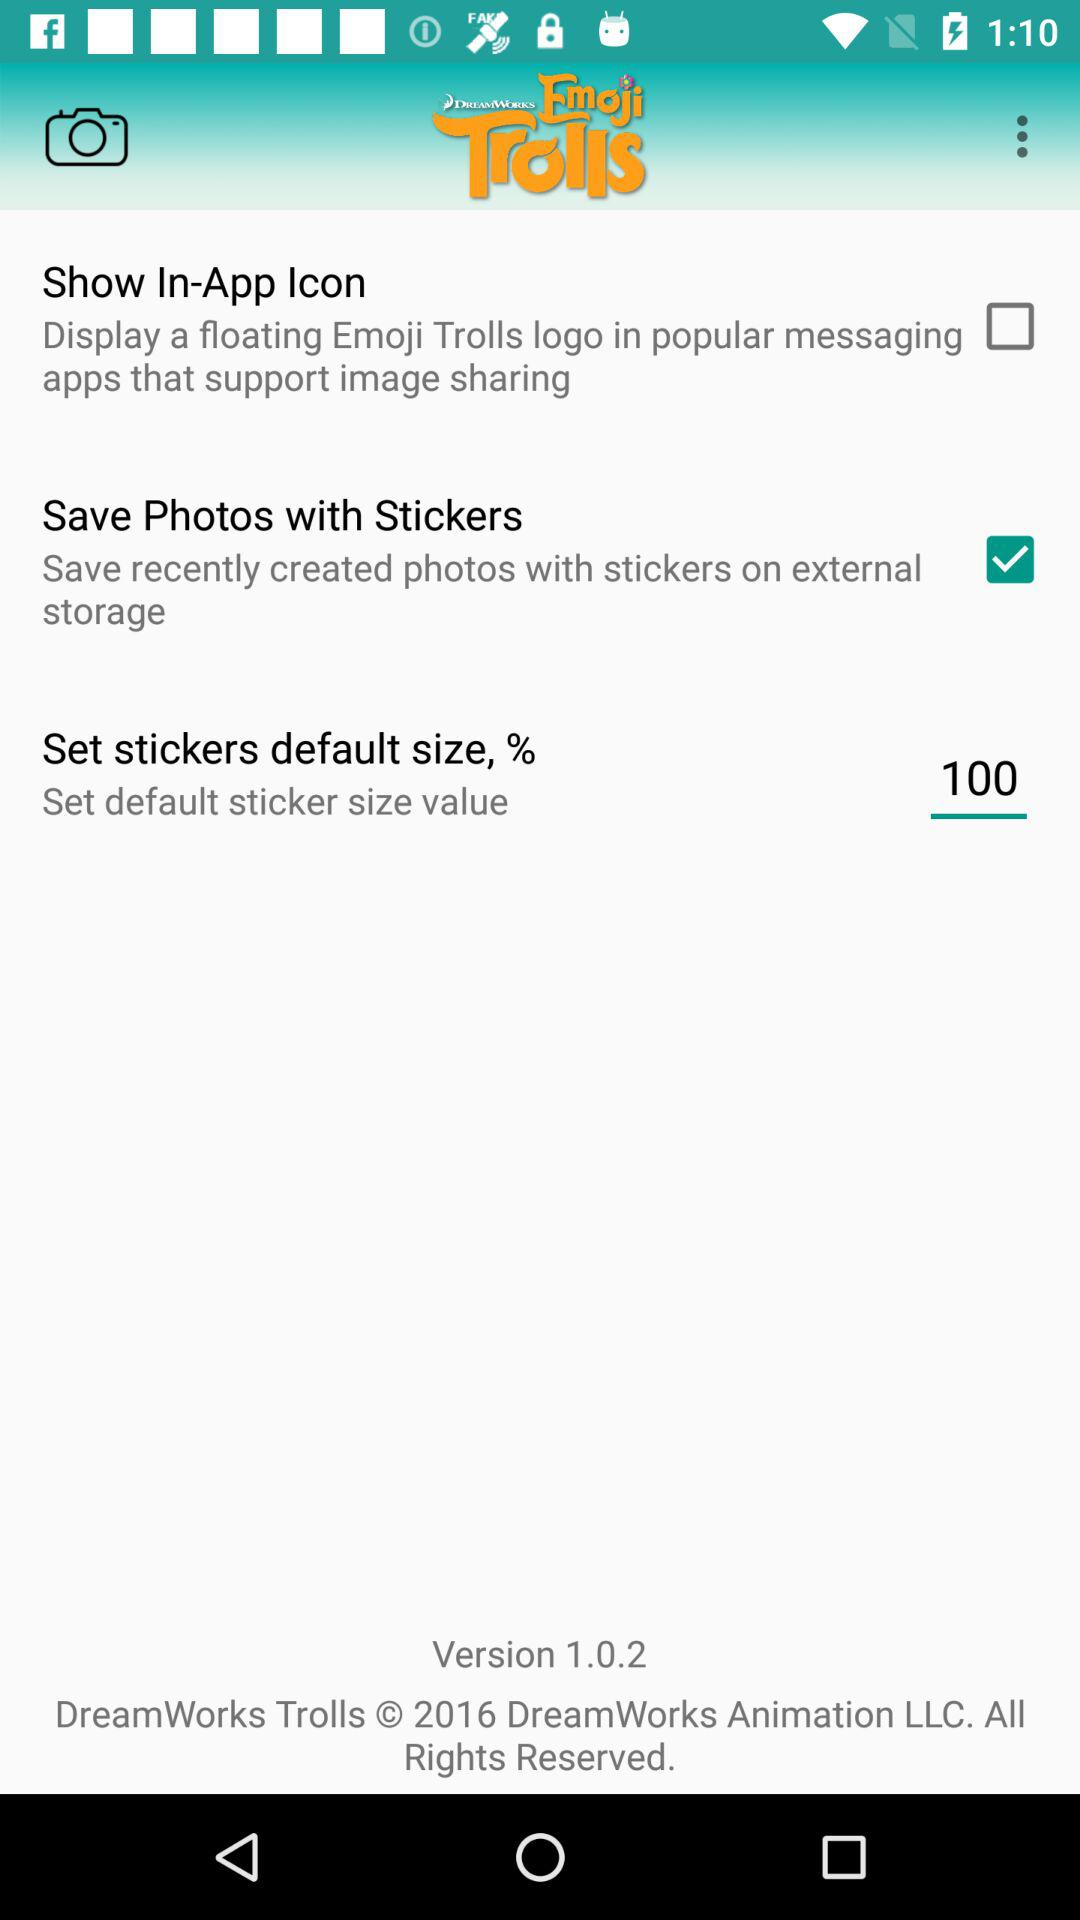What's the default value for sticker size? The default value is 100. 